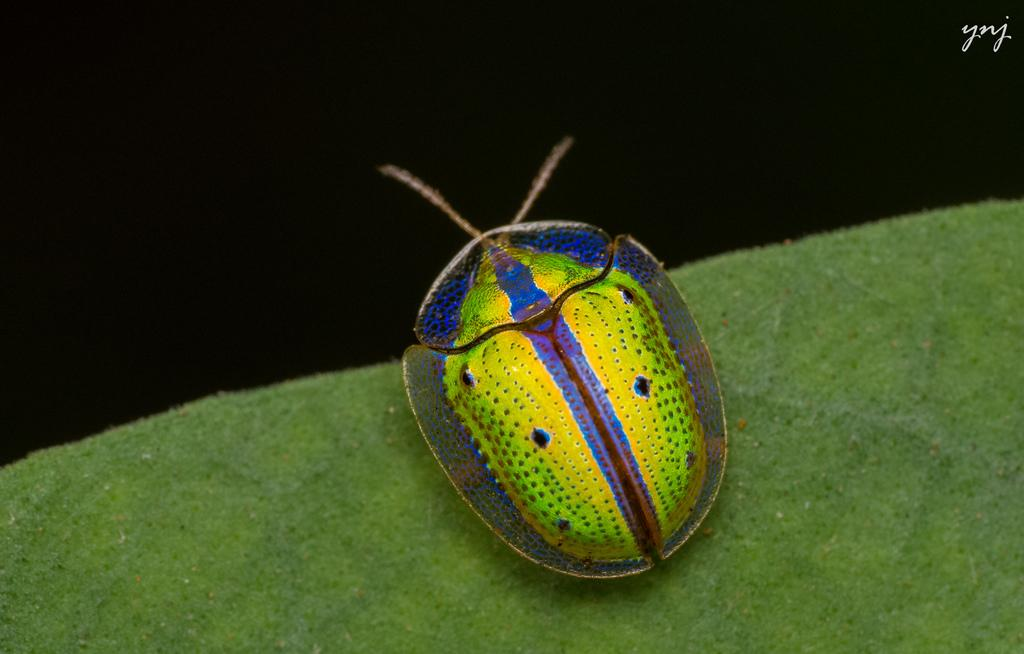What type of creature can be seen in the image? There is an insect in the image. What is the color of the surface where the insect is located? The insect is on a green surface. What can be observed about the background of the image? The background of the image is dark. How many potatoes are visible in the image? There are no potatoes present in the image. What type of bikes can be seen in the image? There are no bikes present in the image. 